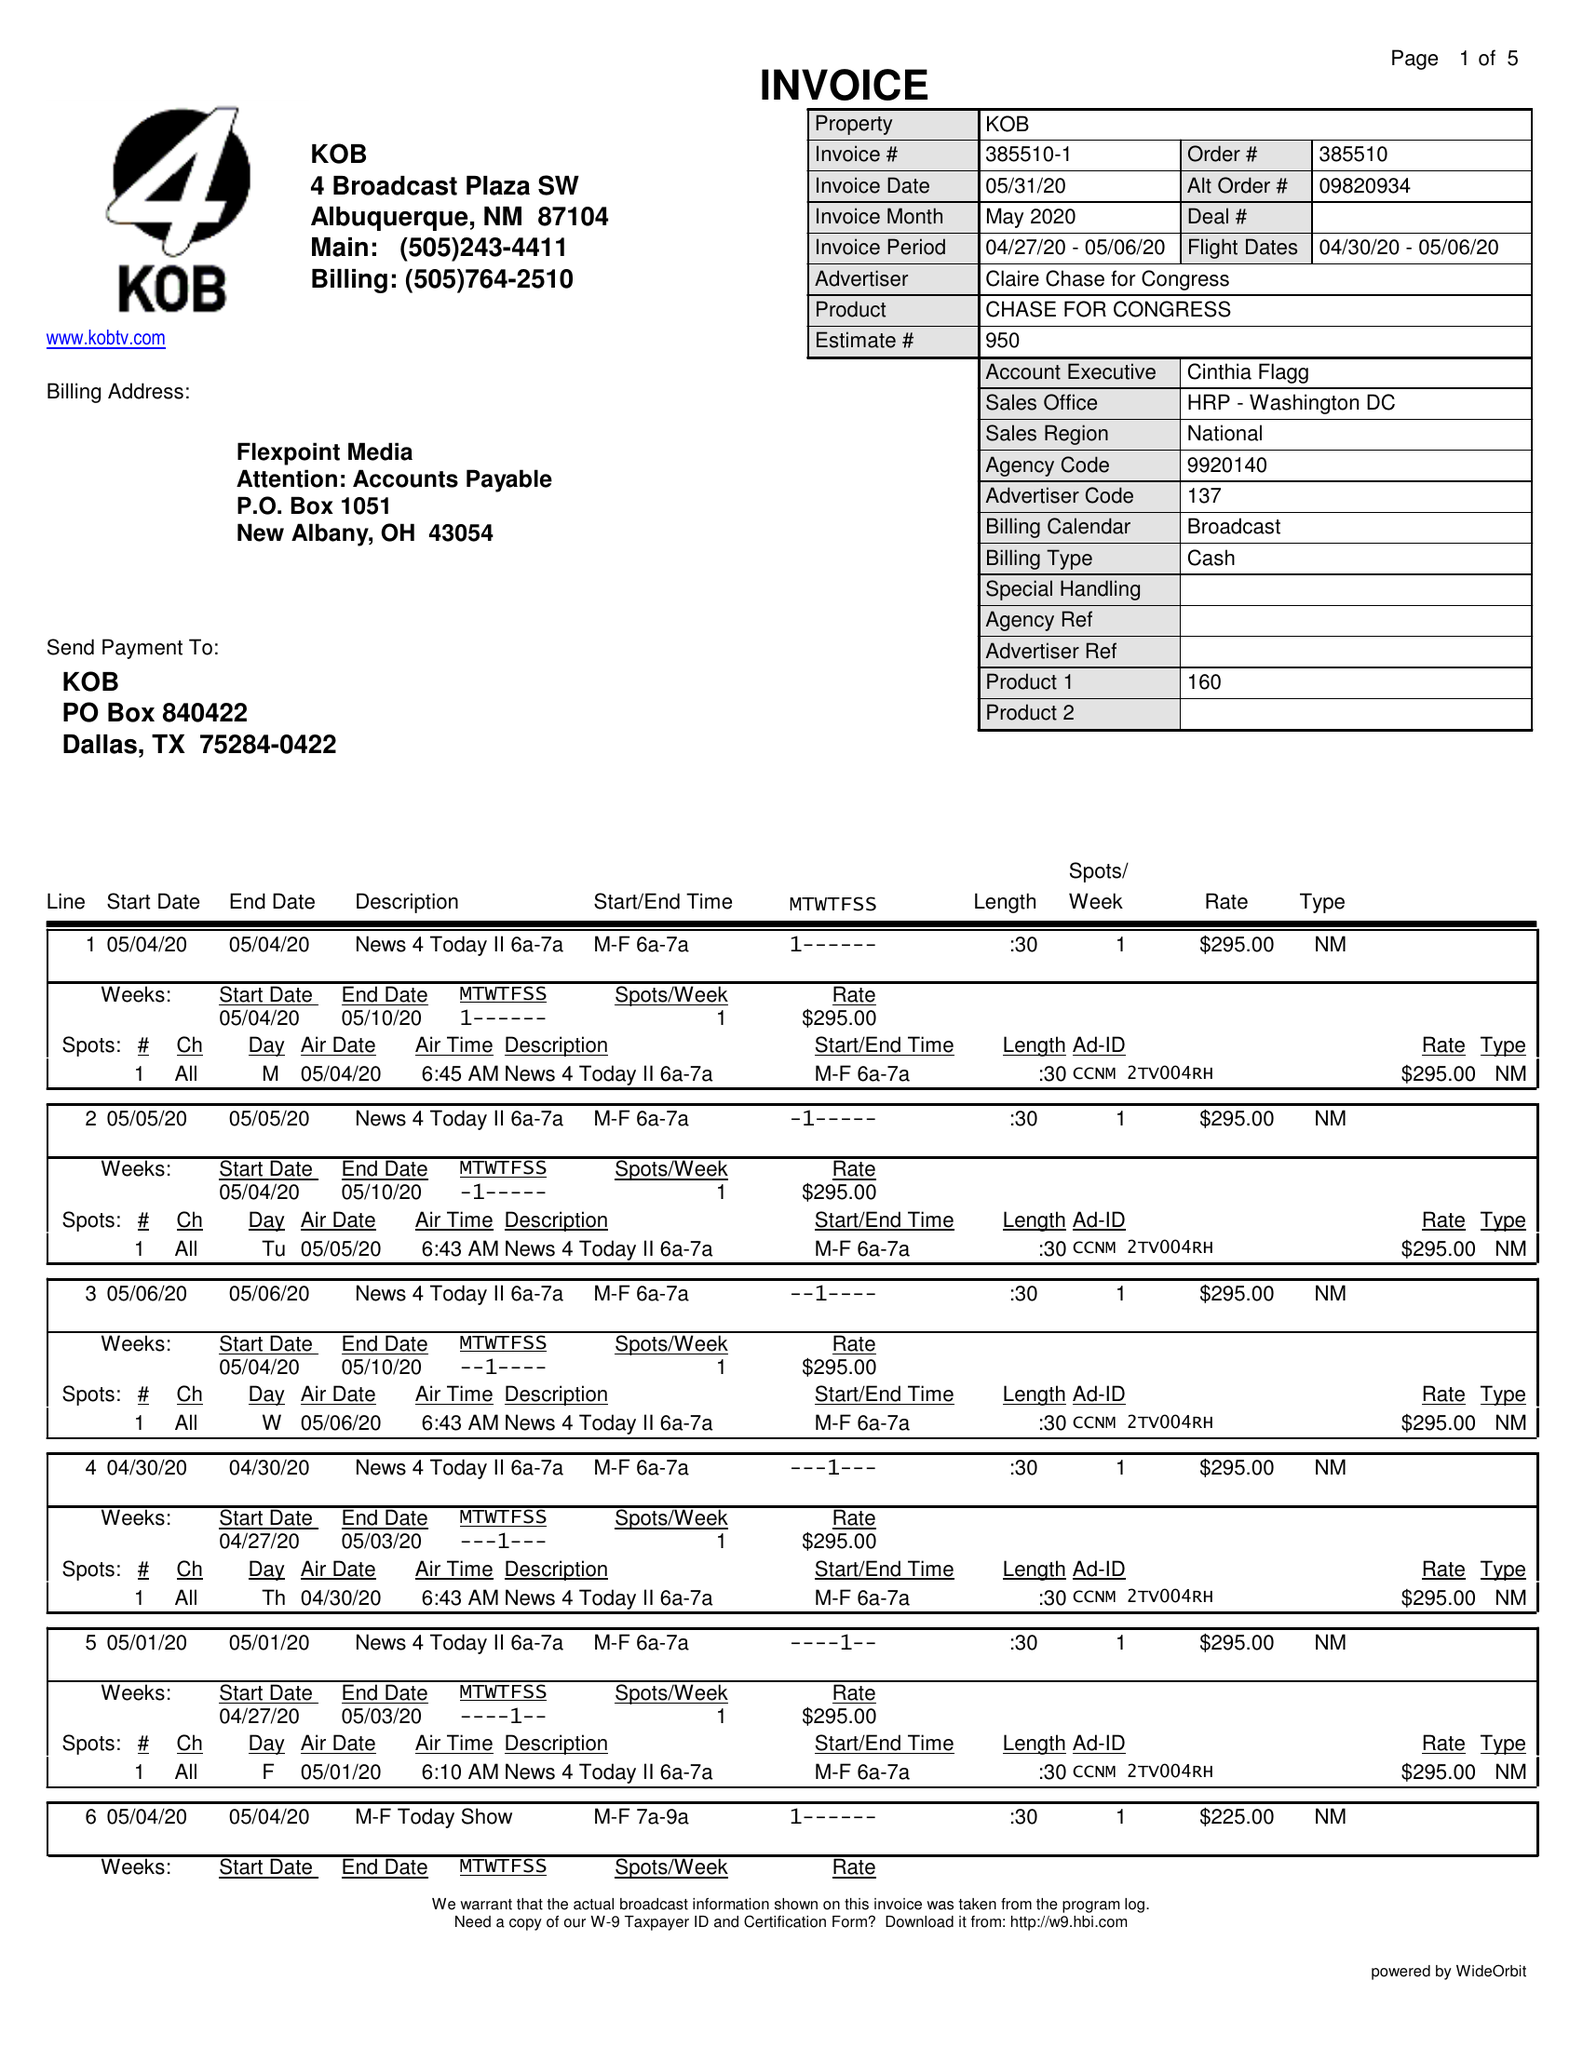What is the value for the flight_to?
Answer the question using a single word or phrase. 05/06/20 